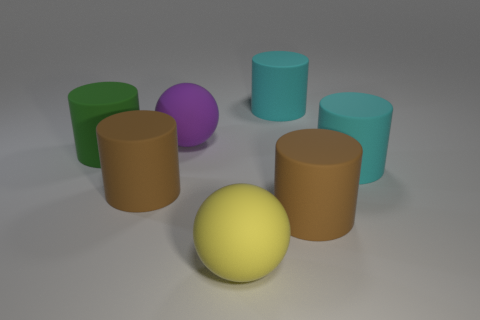What number of purple rubber things are the same size as the green object?
Make the answer very short. 1. Do the brown cylinder on the right side of the yellow rubber object and the big purple object have the same size?
Offer a very short reply. Yes. What is the shape of the big yellow thing?
Your response must be concise. Sphere. Does the sphere that is right of the large purple rubber ball have the same material as the large purple ball?
Your answer should be very brief. Yes. There is a big purple matte object that is behind the big yellow thing; does it have the same shape as the big yellow rubber thing that is on the right side of the green rubber cylinder?
Offer a very short reply. Yes. Are there any big yellow things that have the same material as the green cylinder?
Keep it short and to the point. Yes. What number of blue objects are either rubber spheres or cylinders?
Your response must be concise. 0. How big is the cylinder that is both in front of the big green rubber cylinder and on the left side of the big purple rubber thing?
Give a very brief answer. Large. Are there more big purple spheres on the right side of the green matte cylinder than large green blocks?
Ensure brevity in your answer.  Yes. How many spheres are yellow objects or purple objects?
Provide a succinct answer. 2. 